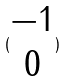<formula> <loc_0><loc_0><loc_500><loc_500>( \begin{matrix} - 1 \\ 0 \end{matrix} )</formula> 